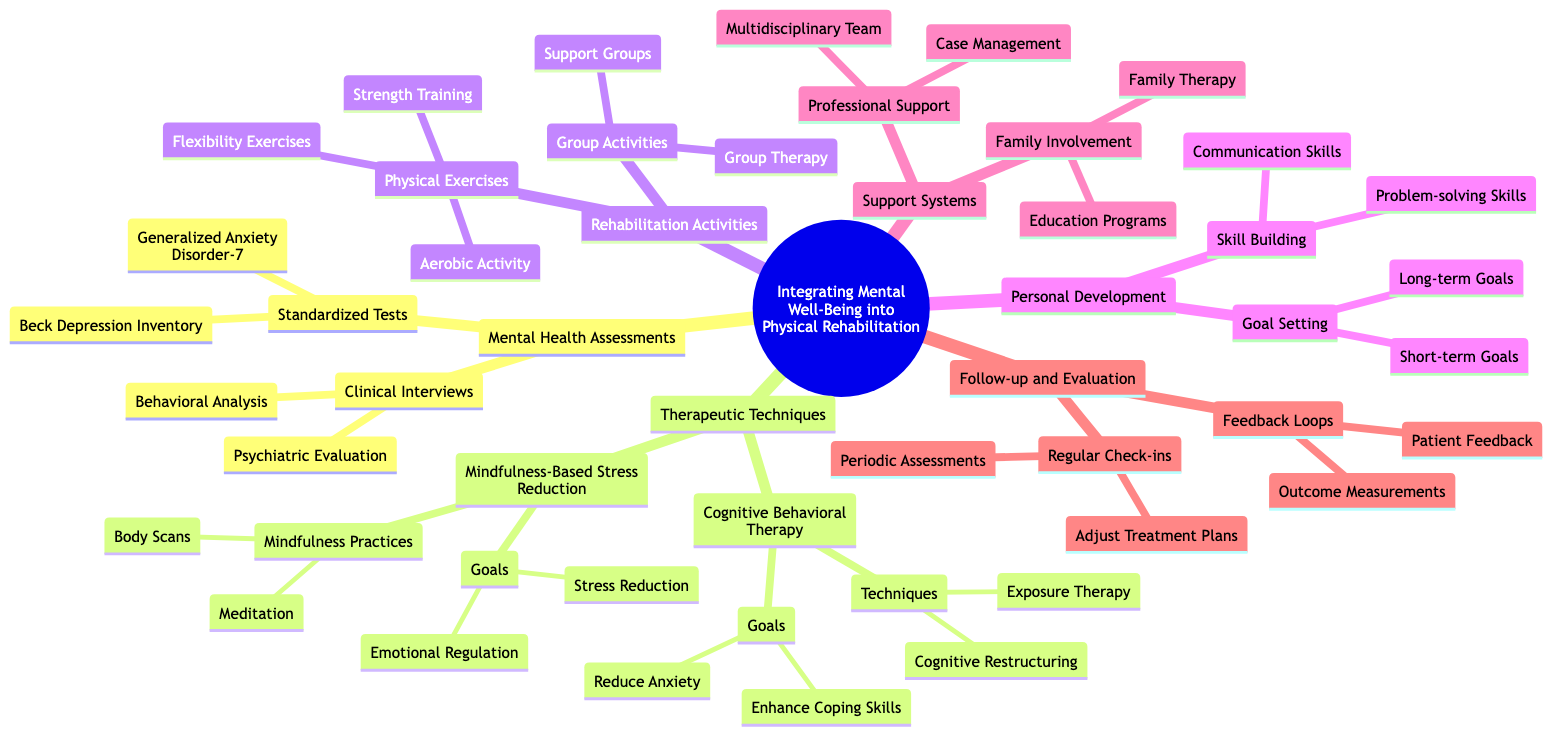What are the two types of Mental Health Assessments? The diagram lists two main types under "Mental Health Assessments": "Clinical Interviews" and "Standardized Tests". These categories encompass the various methods used to evaluate mental health in a rehabilitation context.
Answer: Clinical Interviews, Standardized Tests How many therapeutic techniques are listed? Under "Therapeutic Techniques", the diagram identifies two primary methods: "Cognitive Behavioral Therapy (CBT)" and "Mindfulness-Based Stress Reduction (MBSR)". Thus, there are a total of two therapeutic techniques mentioned.
Answer: 2 What is the goal of Cognitive Restructuring? The diagram states that "Cognitive Restructuring" aims to "Challenge and alter unhelpful thought patterns", which involves changing negative thinking that might hinder rehabilitation efforts.
Answer: Challenge and alter unhelpful thought patterns Which activities fall under Group Activities? Within the section of "Group Activities", the diagram lists two specific activities: "Support Groups" and "Group Therapy". These are aimed at promoting collective healing and mutual support among participants.
Answer: Support Groups, Group Therapy What is the focus of Regular Check-ins? The diagram outlines that "Regular Check-ins" is primarily focused on "Periodic Assessments" and "Adjust Treatment Plans". This indicates that they serve to evaluate patient progress and make necessary modifications to the rehabilitation strategy.
Answer: Periodic Assessments, Adjust Treatment Plans What two skills are targeted in Skill Building? Under "Skill Building", the diagram highlights two specific skills: "Problem-solving Skills" and "Communication Skills". These are essential for personal development during rehabilitation, fostering better interaction and coping abilities.
Answer: Problem-solving Skills, Communication Skills Which test is used to gauge levels of depression? The diagram specifies that the "Beck Depression Inventory" is utilized to assess current levels of depression, making it a crucial tool in the standardized testing segment of mental health assessments.
Answer: Beck Depression Inventory What type of support is provided by the Multidisciplinary Team? The "Professional Support" section notes that the "Multidisciplinary Team" is established to "Collaborate with a team of health professionals", indicating a comprehensive approach to patient care through varied expertise.
Answer: Collaborate with a team of health professionals How many goals are associated with Mindfulness-Based Stress Reduction? The diagram outlines two goals associated with "Mindfulness-Based Stress Reduction": "Stress Reduction" and "Emotional Regulation". This indicates a focus on both decreasing stress levels and improving emotional control.
Answer: 2 